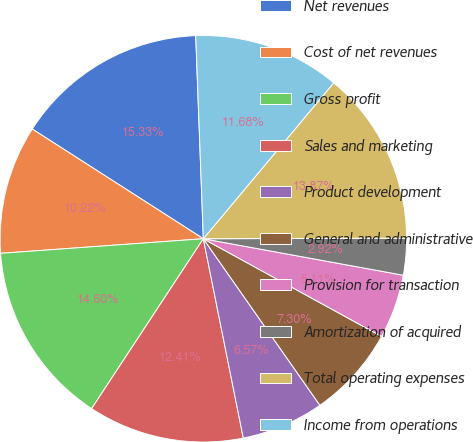<chart> <loc_0><loc_0><loc_500><loc_500><pie_chart><fcel>Net revenues<fcel>Cost of net revenues<fcel>Gross profit<fcel>Sales and marketing<fcel>Product development<fcel>General and administrative<fcel>Provision for transaction<fcel>Amortization of acquired<fcel>Total operating expenses<fcel>Income from operations<nl><fcel>15.33%<fcel>10.22%<fcel>14.6%<fcel>12.41%<fcel>6.57%<fcel>7.3%<fcel>5.11%<fcel>2.92%<fcel>13.87%<fcel>11.68%<nl></chart> 